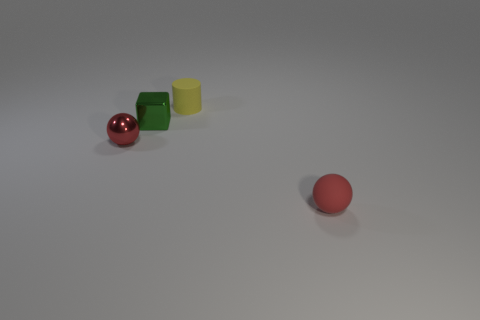Subtract 1 spheres. How many spheres are left? 1 Add 2 small brown shiny objects. How many objects exist? 6 Subtract all cylinders. How many objects are left? 3 Subtract all blue cubes. Subtract all blue balls. How many cubes are left? 1 Subtract all green blocks. How many brown cylinders are left? 0 Subtract all big green metal blocks. Subtract all matte cylinders. How many objects are left? 3 Add 4 tiny cylinders. How many tiny cylinders are left? 5 Add 4 green objects. How many green objects exist? 5 Subtract 0 gray blocks. How many objects are left? 4 